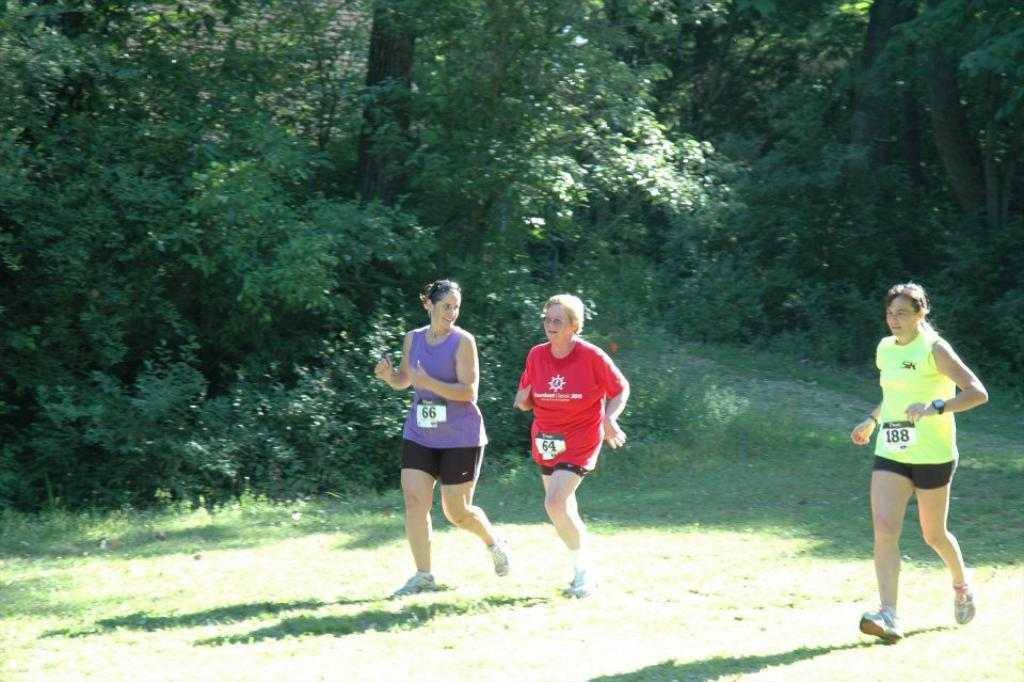What is happening in the foreground of the image? There are people in the foreground of the image, and they appear to be jogging. What type of terrain is the jogging taking place on? The jogging is taking place on a grassland. What can be seen in the background of the image? There are trees in the background of the image. What type of music is playing in the background of the image? There is no music present in the image; it only shows people jogging on a grassland with trees in the background. 